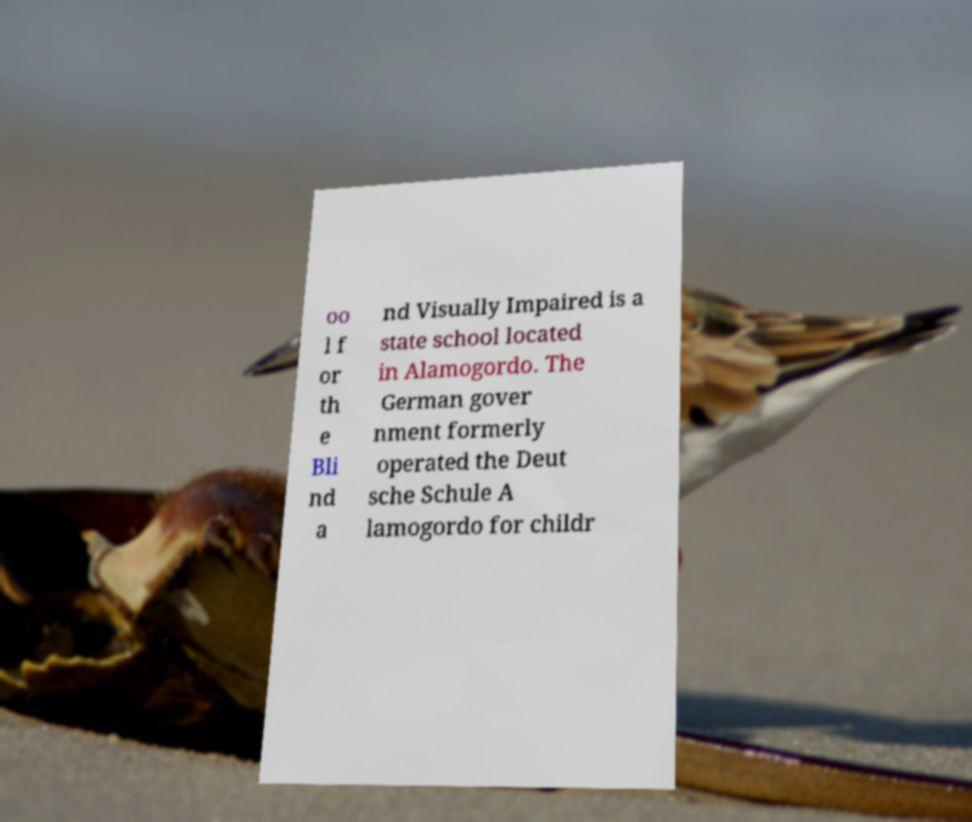I need the written content from this picture converted into text. Can you do that? oo l f or th e Bli nd a nd Visually Impaired is a state school located in Alamogordo. The German gover nment formerly operated the Deut sche Schule A lamogordo for childr 